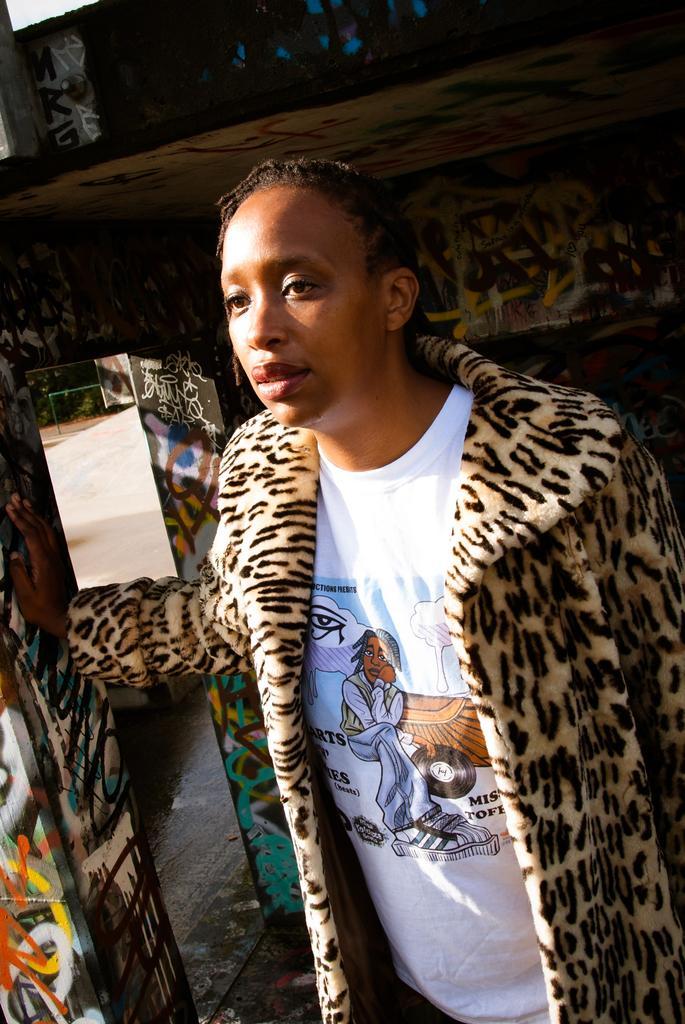Can you describe this image briefly? In this picture we can see a person and in the background we can see some objects. 